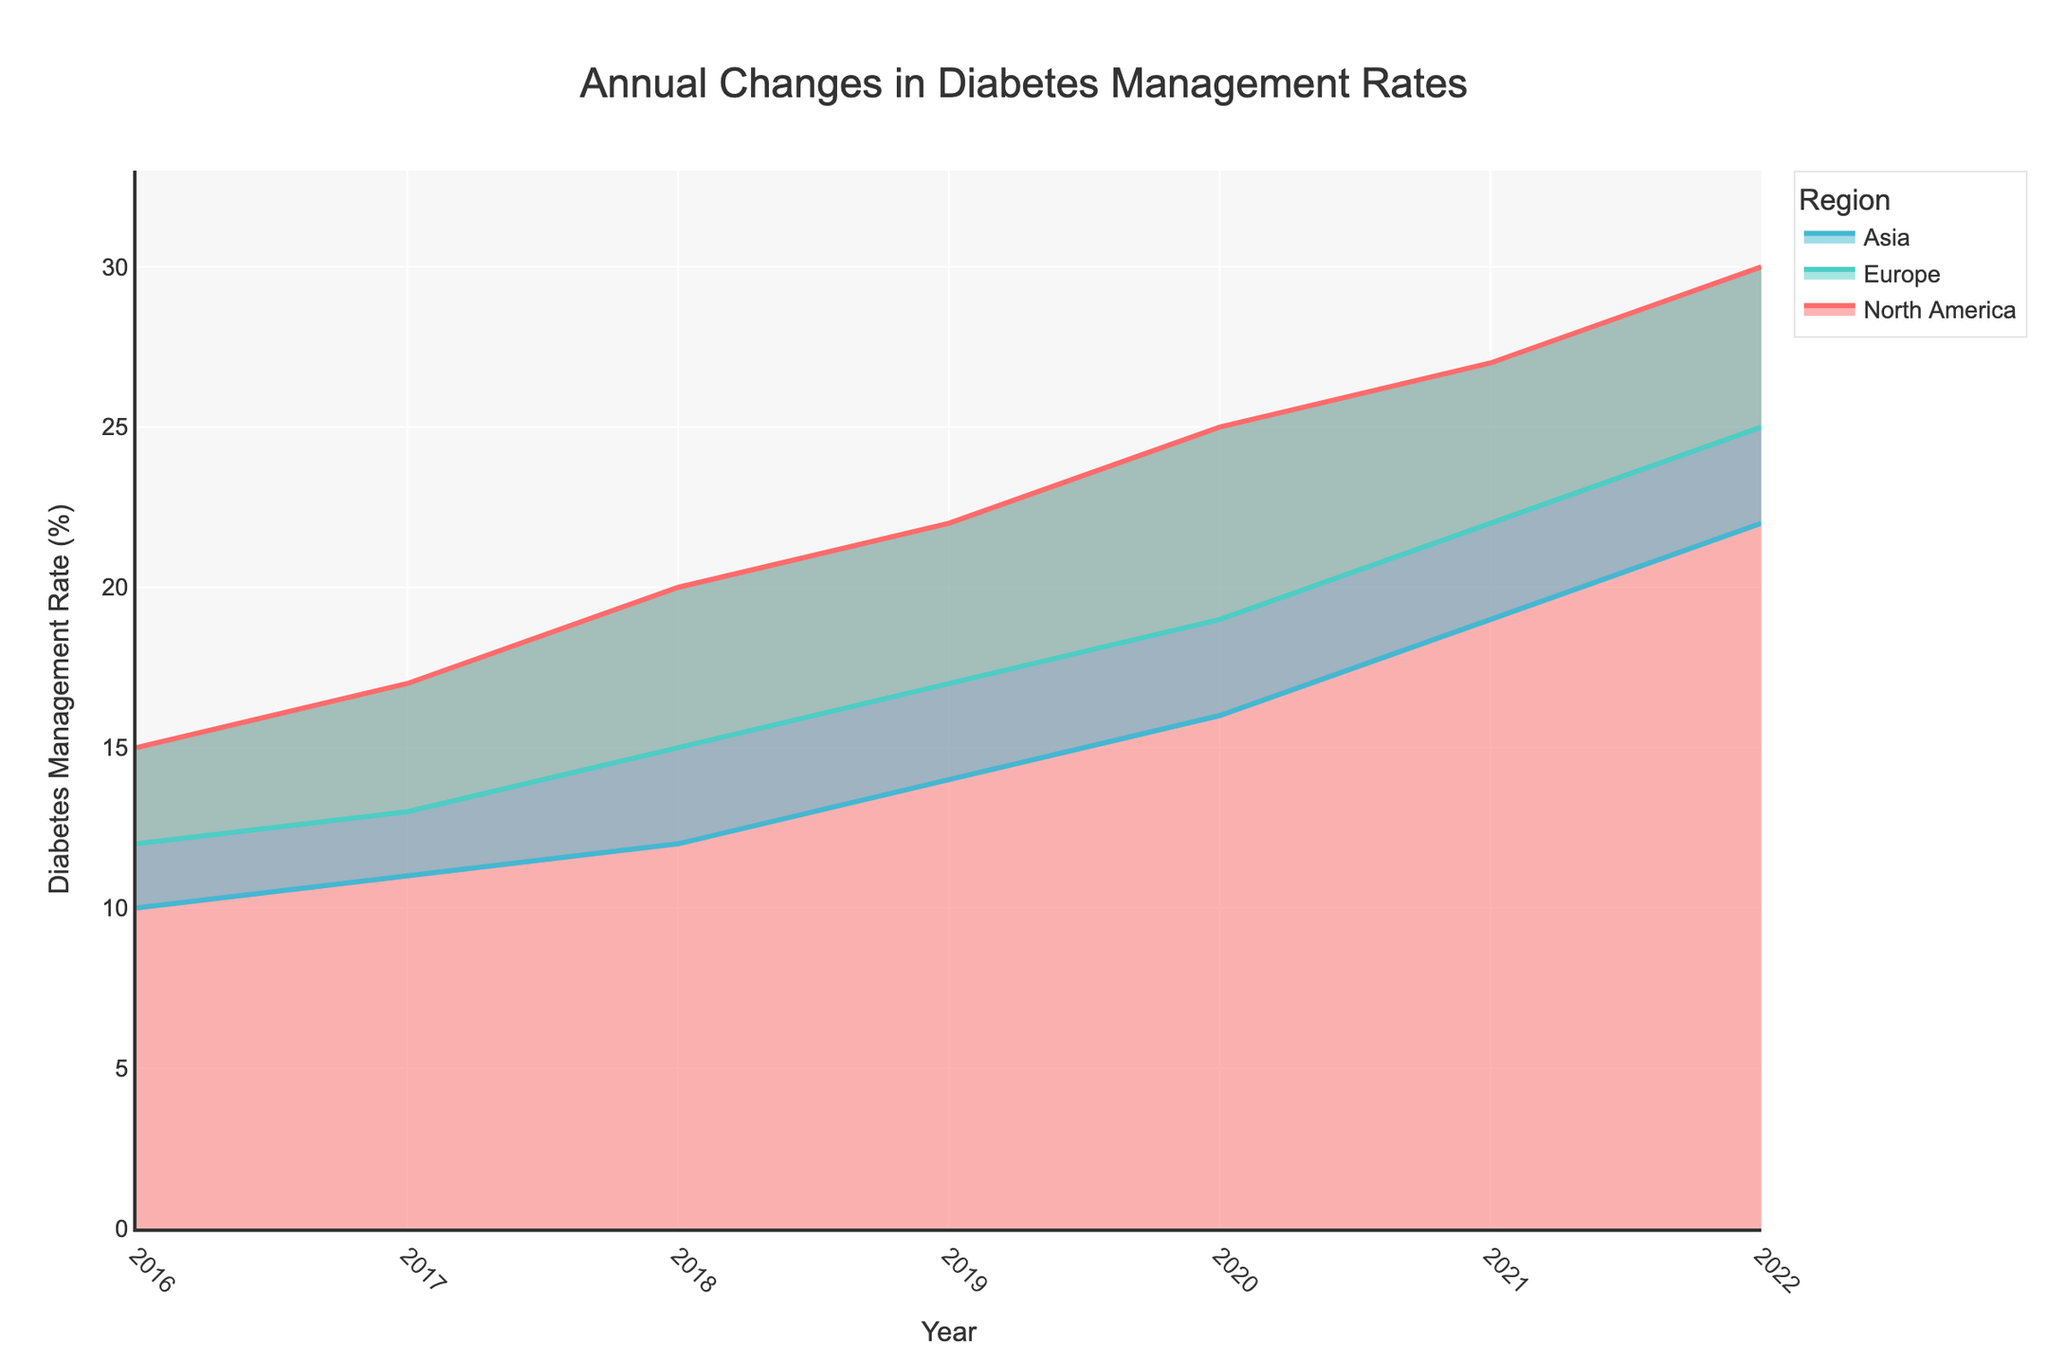What is the title of the chart? The title of the chart is clearly displayed at the top of the figure. By observing the top header of the chart, we can see that it says "Annual Changes in Diabetes Management Rates".
Answer: Annual Changes in Diabetes Management Rates What are the three regions represented in the chart? The chart has a legend indicating the different regions. By looking at the legend, we can see that the three regions are North America, Europe, and Asia.
Answer: North America, Europe, Asia In which year did North America have the highest Diabetes Management Rate (%)? By examining the trend of the red line on the chart (which represents North America), we see that the highest point is reached in the year 2022 where the value is 30%.
Answer: 2022 What are the colors used to represent each region? The chart's legend indicates that North America is represented by red, Europe by green, and Asia by blue. These colors are consistently used to depict the regions in the step area chart.
Answer: North America: red, Europe: green, Asia: blue What is the difference in Diabetes Management Rate (%) between Europe and Asia in the year 2020? For the year 2020, observe the values at the vertical intersections for the green (Europe) and blue (Asia) areas. Europe has a rate of 19%, and Asia has a rate of 16%. The difference is computed as 19% - 16%.
Answer: 3% Between which years did Europe see the most significant year-over-year increase in its Diabetes Management Rate (%)? By closely examining the increments of the green line (Europe) from year to year, the biggest jump is noticed between 2020 and 2021, where the value increases from 19% to 22%.
Answer: 2020-2021 Which region showed the least growth in its Diabetes Management Rate (%) from 2016 to 2022? By comparing the growth of all regions from 2016 to 2022, North America increased from 15% to 30% (a difference of 15%), Europe from 12% to 25% (a difference of 13%), and Asia from 10% to 22% (a difference of 12%). Asia has the smallest growth.
Answer: Asia What is the combined Diabetes Management Rate (%) of all regions in 2018? To find the combined rate for all regions in 2018, sum the individual rates for that year. For 2018, North America is 20%, Europe is 15%, and Asia is 12%. The combined rate is 20% + 15% + 12%.
Answer: 47% Which region had the most consistent increase in their Diabetes Management Rate (%) over the years? By observing the progression of the lines visually and noting the changes in each region's values year-on-year, Europe (depicted in green) shows a steady linear increase each year without sudden jumps.
Answer: Europe How does the Diabetes Management Rate (%) of North America in 2022 compare to Asia's rate in 2019? Look at the figure to locate North America's rate in 2022 which is 30%, and Asia's rate in 2019 which is 14%. Compare the two values to see that North America's rate in 2022 is more than double Asia's rate in 2019.
Answer: North America in 2022's rate is more than double Asia's rate in 2019 